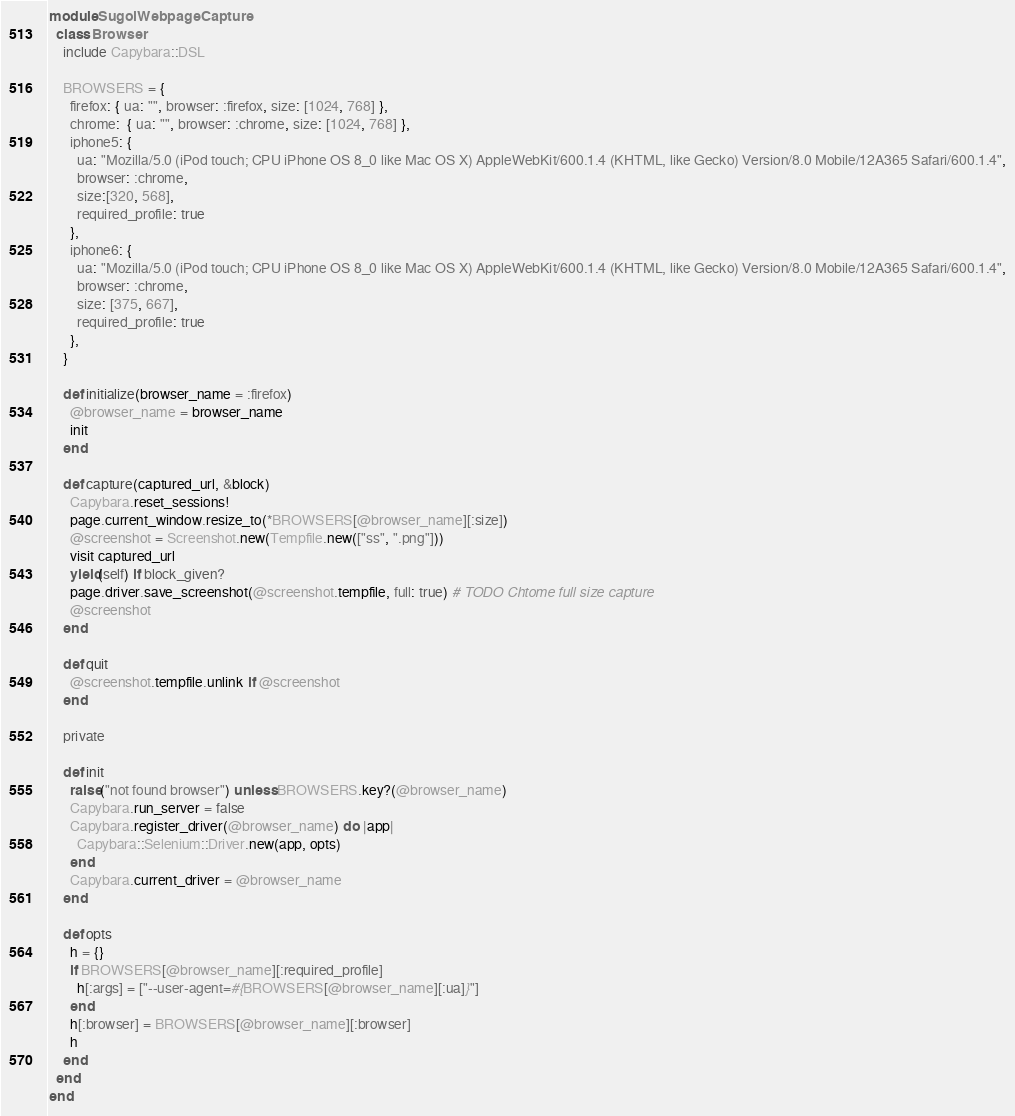<code> <loc_0><loc_0><loc_500><loc_500><_Ruby_>module SugoiWebpageCapture
  class Browser
    include Capybara::DSL

    BROWSERS = {
      firefox: { ua: "", browser: :firefox, size: [1024, 768] },
      chrome:  { ua: "", browser: :chrome, size: [1024, 768] },
      iphone5: {
        ua: "Mozilla/5.0 (iPod touch; CPU iPhone OS 8_0 like Mac OS X) AppleWebKit/600.1.4 (KHTML, like Gecko) Version/8.0 Mobile/12A365 Safari/600.1.4",
        browser: :chrome,
        size:[320, 568],
        required_profile: true
      },
      iphone6: {
        ua: "Mozilla/5.0 (iPod touch; CPU iPhone OS 8_0 like Mac OS X) AppleWebKit/600.1.4 (KHTML, like Gecko) Version/8.0 Mobile/12A365 Safari/600.1.4",
        browser: :chrome,
        size: [375, 667],
        required_profile: true
      },
    }

    def initialize(browser_name = :firefox)
      @browser_name = browser_name
      init
    end

    def capture(captured_url, &block)
      Capybara.reset_sessions!
      page.current_window.resize_to(*BROWSERS[@browser_name][:size])
      @screenshot = Screenshot.new(Tempfile.new(["ss", ".png"]))
      visit captured_url
      yield(self) if block_given?
      page.driver.save_screenshot(@screenshot.tempfile, full: true) # TODO Chtome full size capture
      @screenshot
    end

    def quit
      @screenshot.tempfile.unlink if @screenshot
    end

    private

    def init
      raise("not found browser") unless BROWSERS.key?(@browser_name)
      Capybara.run_server = false
      Capybara.register_driver(@browser_name) do |app|
        Capybara::Selenium::Driver.new(app, opts)
      end
      Capybara.current_driver = @browser_name
    end

    def opts
      h = {}
      if BROWSERS[@browser_name][:required_profile]
        h[:args] = ["--user-agent=#{BROWSERS[@browser_name][:ua]}"]
      end
      h[:browser] = BROWSERS[@browser_name][:browser]
      h
    end
  end
end
</code> 